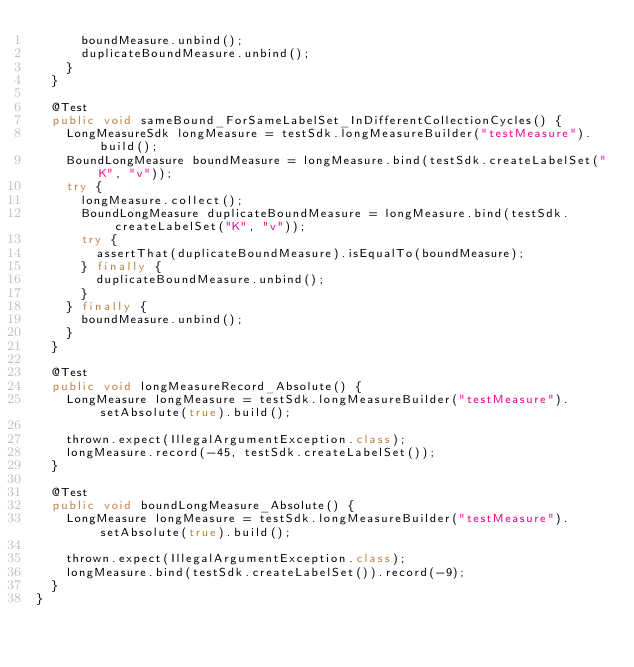<code> <loc_0><loc_0><loc_500><loc_500><_Java_>      boundMeasure.unbind();
      duplicateBoundMeasure.unbind();
    }
  }

  @Test
  public void sameBound_ForSameLabelSet_InDifferentCollectionCycles() {
    LongMeasureSdk longMeasure = testSdk.longMeasureBuilder("testMeasure").build();
    BoundLongMeasure boundMeasure = longMeasure.bind(testSdk.createLabelSet("K", "v"));
    try {
      longMeasure.collect();
      BoundLongMeasure duplicateBoundMeasure = longMeasure.bind(testSdk.createLabelSet("K", "v"));
      try {
        assertThat(duplicateBoundMeasure).isEqualTo(boundMeasure);
      } finally {
        duplicateBoundMeasure.unbind();
      }
    } finally {
      boundMeasure.unbind();
    }
  }

  @Test
  public void longMeasureRecord_Absolute() {
    LongMeasure longMeasure = testSdk.longMeasureBuilder("testMeasure").setAbsolute(true).build();

    thrown.expect(IllegalArgumentException.class);
    longMeasure.record(-45, testSdk.createLabelSet());
  }

  @Test
  public void boundLongMeasure_Absolute() {
    LongMeasure longMeasure = testSdk.longMeasureBuilder("testMeasure").setAbsolute(true).build();

    thrown.expect(IllegalArgumentException.class);
    longMeasure.bind(testSdk.createLabelSet()).record(-9);
  }
}
</code> 